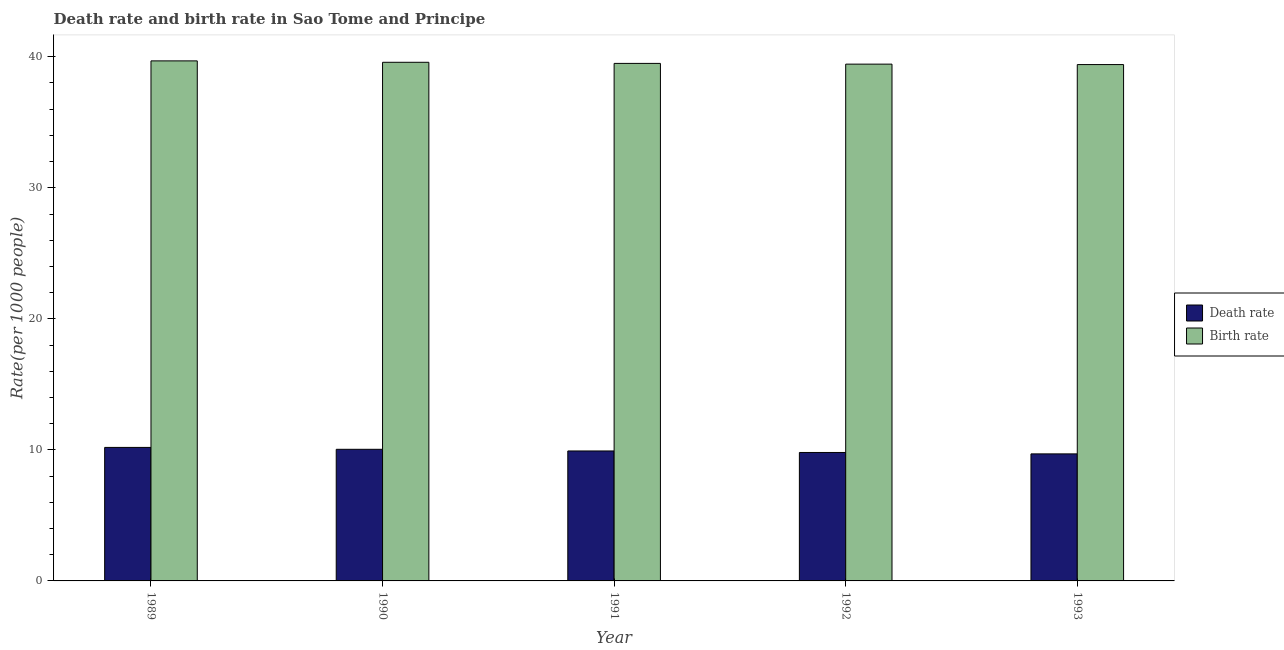How many different coloured bars are there?
Your answer should be very brief. 2. How many groups of bars are there?
Offer a very short reply. 5. Are the number of bars per tick equal to the number of legend labels?
Give a very brief answer. Yes. What is the label of the 2nd group of bars from the left?
Your response must be concise. 1990. In how many cases, is the number of bars for a given year not equal to the number of legend labels?
Your answer should be very brief. 0. What is the birth rate in 1990?
Make the answer very short. 39.58. Across all years, what is the maximum birth rate?
Your response must be concise. 39.69. Across all years, what is the minimum birth rate?
Your answer should be very brief. 39.4. In which year was the birth rate maximum?
Offer a very short reply. 1989. What is the total birth rate in the graph?
Provide a succinct answer. 197.59. What is the difference between the death rate in 1989 and that in 1991?
Your answer should be very brief. 0.27. What is the difference between the birth rate in 1991 and the death rate in 1993?
Your response must be concise. 0.09. What is the average death rate per year?
Ensure brevity in your answer.  9.93. In how many years, is the death rate greater than 10?
Provide a succinct answer. 2. What is the ratio of the death rate in 1989 to that in 1993?
Give a very brief answer. 1.05. Is the birth rate in 1989 less than that in 1990?
Ensure brevity in your answer.  No. Is the difference between the birth rate in 1992 and 1993 greater than the difference between the death rate in 1992 and 1993?
Provide a short and direct response. No. What is the difference between the highest and the second highest birth rate?
Make the answer very short. 0.11. What is the difference between the highest and the lowest death rate?
Keep it short and to the point. 0.49. What does the 1st bar from the left in 1993 represents?
Keep it short and to the point. Death rate. What does the 1st bar from the right in 1990 represents?
Your answer should be very brief. Birth rate. What is the difference between two consecutive major ticks on the Y-axis?
Your answer should be very brief. 10. Does the graph contain any zero values?
Your response must be concise. No. Does the graph contain grids?
Offer a very short reply. No. Where does the legend appear in the graph?
Provide a succinct answer. Center right. What is the title of the graph?
Provide a short and direct response. Death rate and birth rate in Sao Tome and Principe. What is the label or title of the X-axis?
Your answer should be compact. Year. What is the label or title of the Y-axis?
Offer a terse response. Rate(per 1000 people). What is the Rate(per 1000 people) in Death rate in 1989?
Ensure brevity in your answer.  10.19. What is the Rate(per 1000 people) of Birth rate in 1989?
Provide a succinct answer. 39.69. What is the Rate(per 1000 people) in Death rate in 1990?
Give a very brief answer. 10.04. What is the Rate(per 1000 people) of Birth rate in 1990?
Offer a terse response. 39.58. What is the Rate(per 1000 people) of Death rate in 1991?
Your answer should be very brief. 9.92. What is the Rate(per 1000 people) in Birth rate in 1991?
Give a very brief answer. 39.49. What is the Rate(per 1000 people) of Death rate in 1992?
Make the answer very short. 9.8. What is the Rate(per 1000 people) in Birth rate in 1992?
Offer a very short reply. 39.44. What is the Rate(per 1000 people) in Death rate in 1993?
Offer a very short reply. 9.69. What is the Rate(per 1000 people) of Birth rate in 1993?
Provide a succinct answer. 39.4. Across all years, what is the maximum Rate(per 1000 people) in Death rate?
Your answer should be very brief. 10.19. Across all years, what is the maximum Rate(per 1000 people) of Birth rate?
Provide a short and direct response. 39.69. Across all years, what is the minimum Rate(per 1000 people) of Death rate?
Offer a terse response. 9.69. Across all years, what is the minimum Rate(per 1000 people) of Birth rate?
Offer a very short reply. 39.4. What is the total Rate(per 1000 people) in Death rate in the graph?
Make the answer very short. 49.65. What is the total Rate(per 1000 people) of Birth rate in the graph?
Offer a very short reply. 197.59. What is the difference between the Rate(per 1000 people) in Death rate in 1989 and that in 1990?
Offer a very short reply. 0.14. What is the difference between the Rate(per 1000 people) in Birth rate in 1989 and that in 1990?
Provide a short and direct response. 0.11. What is the difference between the Rate(per 1000 people) of Death rate in 1989 and that in 1991?
Your response must be concise. 0.27. What is the difference between the Rate(per 1000 people) of Birth rate in 1989 and that in 1991?
Offer a terse response. 0.19. What is the difference between the Rate(per 1000 people) in Death rate in 1989 and that in 1992?
Provide a succinct answer. 0.39. What is the difference between the Rate(per 1000 people) of Birth rate in 1989 and that in 1992?
Make the answer very short. 0.25. What is the difference between the Rate(per 1000 people) in Death rate in 1989 and that in 1993?
Provide a succinct answer. 0.49. What is the difference between the Rate(per 1000 people) in Birth rate in 1989 and that in 1993?
Provide a succinct answer. 0.28. What is the difference between the Rate(per 1000 people) of Death rate in 1990 and that in 1991?
Offer a terse response. 0.13. What is the difference between the Rate(per 1000 people) of Birth rate in 1990 and that in 1991?
Ensure brevity in your answer.  0.08. What is the difference between the Rate(per 1000 people) in Death rate in 1990 and that in 1992?
Provide a succinct answer. 0.24. What is the difference between the Rate(per 1000 people) of Birth rate in 1990 and that in 1992?
Offer a terse response. 0.14. What is the difference between the Rate(per 1000 people) in Death rate in 1990 and that in 1993?
Give a very brief answer. 0.35. What is the difference between the Rate(per 1000 people) of Birth rate in 1990 and that in 1993?
Your answer should be compact. 0.17. What is the difference between the Rate(per 1000 people) in Death rate in 1991 and that in 1992?
Offer a terse response. 0.12. What is the difference between the Rate(per 1000 people) in Birth rate in 1991 and that in 1992?
Your answer should be very brief. 0.06. What is the difference between the Rate(per 1000 people) in Death rate in 1991 and that in 1993?
Your answer should be very brief. 0.22. What is the difference between the Rate(per 1000 people) in Birth rate in 1991 and that in 1993?
Give a very brief answer. 0.09. What is the difference between the Rate(per 1000 people) of Death rate in 1992 and that in 1993?
Make the answer very short. 0.11. What is the difference between the Rate(per 1000 people) in Birth rate in 1992 and that in 1993?
Offer a terse response. 0.03. What is the difference between the Rate(per 1000 people) in Death rate in 1989 and the Rate(per 1000 people) in Birth rate in 1990?
Provide a short and direct response. -29.39. What is the difference between the Rate(per 1000 people) of Death rate in 1989 and the Rate(per 1000 people) of Birth rate in 1991?
Your answer should be very brief. -29.3. What is the difference between the Rate(per 1000 people) in Death rate in 1989 and the Rate(per 1000 people) in Birth rate in 1992?
Provide a short and direct response. -29.25. What is the difference between the Rate(per 1000 people) in Death rate in 1989 and the Rate(per 1000 people) in Birth rate in 1993?
Provide a succinct answer. -29.21. What is the difference between the Rate(per 1000 people) of Death rate in 1990 and the Rate(per 1000 people) of Birth rate in 1991?
Your answer should be compact. -29.45. What is the difference between the Rate(per 1000 people) of Death rate in 1990 and the Rate(per 1000 people) of Birth rate in 1992?
Give a very brief answer. -29.39. What is the difference between the Rate(per 1000 people) in Death rate in 1990 and the Rate(per 1000 people) in Birth rate in 1993?
Your answer should be very brief. -29.36. What is the difference between the Rate(per 1000 people) in Death rate in 1991 and the Rate(per 1000 people) in Birth rate in 1992?
Offer a terse response. -29.52. What is the difference between the Rate(per 1000 people) of Death rate in 1991 and the Rate(per 1000 people) of Birth rate in 1993?
Give a very brief answer. -29.49. What is the difference between the Rate(per 1000 people) of Death rate in 1992 and the Rate(per 1000 people) of Birth rate in 1993?
Give a very brief answer. -29.6. What is the average Rate(per 1000 people) in Death rate per year?
Keep it short and to the point. 9.93. What is the average Rate(per 1000 people) in Birth rate per year?
Offer a very short reply. 39.52. In the year 1989, what is the difference between the Rate(per 1000 people) of Death rate and Rate(per 1000 people) of Birth rate?
Keep it short and to the point. -29.5. In the year 1990, what is the difference between the Rate(per 1000 people) of Death rate and Rate(per 1000 people) of Birth rate?
Your answer should be compact. -29.53. In the year 1991, what is the difference between the Rate(per 1000 people) in Death rate and Rate(per 1000 people) in Birth rate?
Your answer should be very brief. -29.58. In the year 1992, what is the difference between the Rate(per 1000 people) in Death rate and Rate(per 1000 people) in Birth rate?
Ensure brevity in your answer.  -29.63. In the year 1993, what is the difference between the Rate(per 1000 people) of Death rate and Rate(per 1000 people) of Birth rate?
Offer a very short reply. -29.71. What is the ratio of the Rate(per 1000 people) in Death rate in 1989 to that in 1990?
Your answer should be very brief. 1.01. What is the ratio of the Rate(per 1000 people) in Birth rate in 1989 to that in 1990?
Ensure brevity in your answer.  1. What is the ratio of the Rate(per 1000 people) in Death rate in 1989 to that in 1991?
Make the answer very short. 1.03. What is the ratio of the Rate(per 1000 people) of Birth rate in 1989 to that in 1991?
Offer a very short reply. 1. What is the ratio of the Rate(per 1000 people) in Death rate in 1989 to that in 1992?
Keep it short and to the point. 1.04. What is the ratio of the Rate(per 1000 people) of Death rate in 1989 to that in 1993?
Your answer should be very brief. 1.05. What is the ratio of the Rate(per 1000 people) of Death rate in 1990 to that in 1991?
Provide a succinct answer. 1.01. What is the ratio of the Rate(per 1000 people) in Death rate in 1990 to that in 1992?
Provide a succinct answer. 1.02. What is the ratio of the Rate(per 1000 people) of Death rate in 1990 to that in 1993?
Provide a succinct answer. 1.04. What is the ratio of the Rate(per 1000 people) in Birth rate in 1990 to that in 1993?
Ensure brevity in your answer.  1. What is the ratio of the Rate(per 1000 people) in Death rate in 1991 to that in 1992?
Your answer should be compact. 1.01. What is the ratio of the Rate(per 1000 people) of Birth rate in 1991 to that in 1992?
Your answer should be very brief. 1. What is the ratio of the Rate(per 1000 people) in Death rate in 1991 to that in 1993?
Give a very brief answer. 1.02. What is the ratio of the Rate(per 1000 people) of Death rate in 1992 to that in 1993?
Your response must be concise. 1.01. What is the difference between the highest and the second highest Rate(per 1000 people) of Death rate?
Ensure brevity in your answer.  0.14. What is the difference between the highest and the second highest Rate(per 1000 people) in Birth rate?
Provide a short and direct response. 0.11. What is the difference between the highest and the lowest Rate(per 1000 people) of Death rate?
Your answer should be compact. 0.49. What is the difference between the highest and the lowest Rate(per 1000 people) in Birth rate?
Provide a succinct answer. 0.28. 